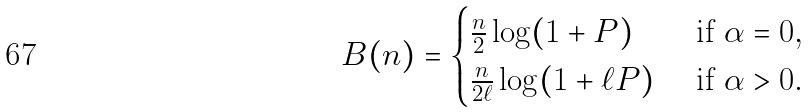Convert formula to latex. <formula><loc_0><loc_0><loc_500><loc_500>B ( n ) = \begin{cases} \frac { n } { 2 } \log ( 1 + P ) & \text { if } \alpha = 0 , \\ \frac { n } { 2 \ell } \log ( 1 + \ell P ) & \text { if } \alpha > 0 . \end{cases}</formula> 